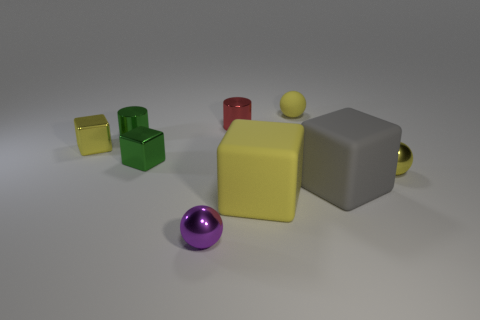There is a tiny yellow object to the left of the small purple sphere; what is it made of?
Your answer should be compact. Metal. There is a red thing that is the same material as the small green cube; what is its size?
Your answer should be very brief. Small. How many other small metallic objects are the same shape as the small purple object?
Ensure brevity in your answer.  1. Do the small matte object and the purple shiny object left of the red cylinder have the same shape?
Provide a short and direct response. Yes. There is a large thing that is the same color as the tiny matte object; what is its shape?
Give a very brief answer. Cube. Are there any big gray cubes that have the same material as the purple sphere?
Give a very brief answer. No. Is there any other thing that has the same material as the tiny red cylinder?
Give a very brief answer. Yes. What material is the yellow sphere to the left of the shiny sphere behind the purple metallic object?
Make the answer very short. Rubber. How big is the shiny cylinder right of the green metal block that is on the left side of the small purple metallic ball that is in front of the red cylinder?
Provide a short and direct response. Small. How many other objects are the same shape as the big gray matte object?
Keep it short and to the point. 3. 